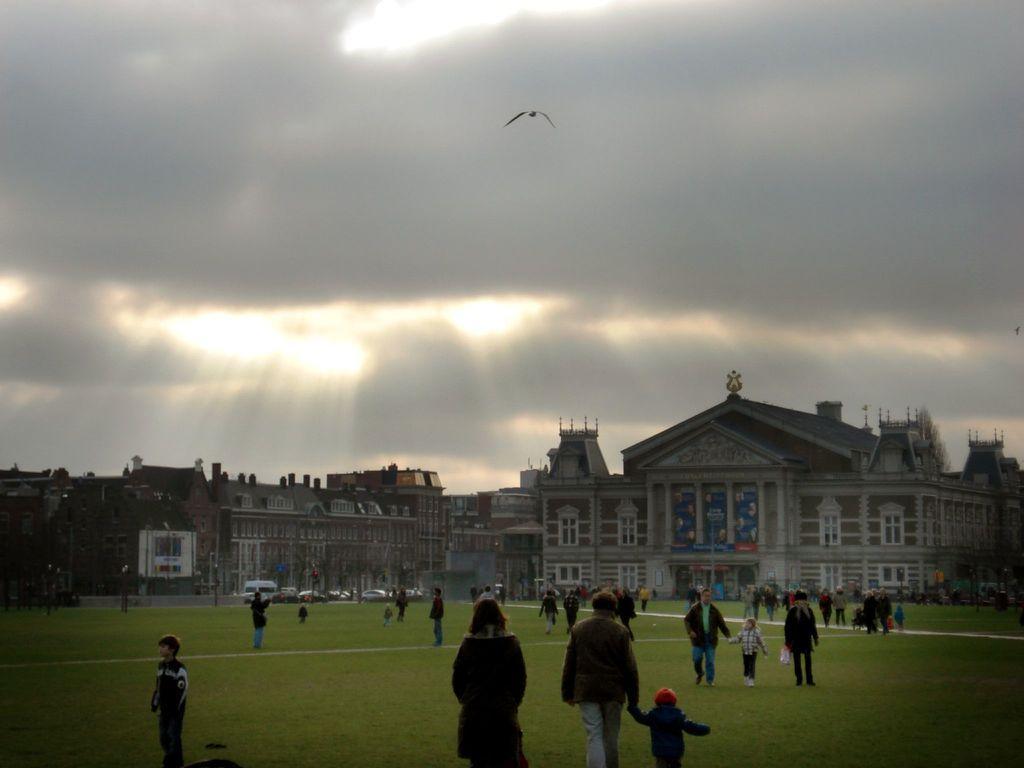Can you describe this image briefly? In this image we can see buildings, persons on the ground, bird and sky with clouds. 